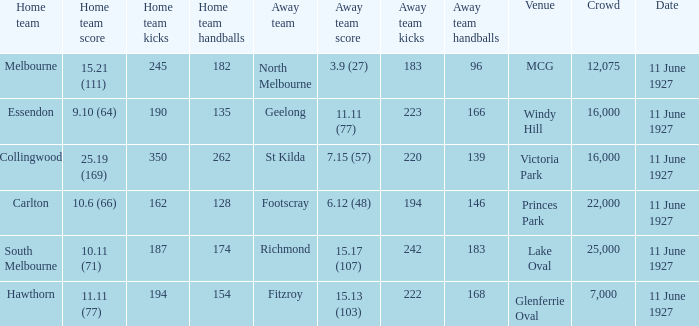Which home team competed against the away team Geelong? Essendon. 